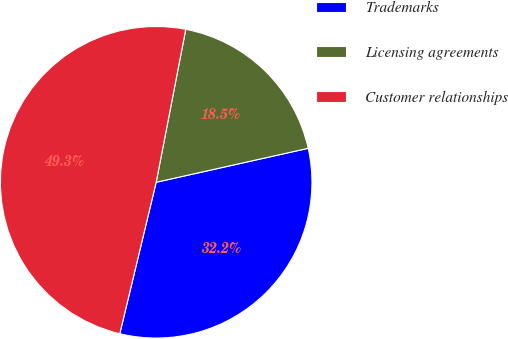Convert chart to OTSL. <chart><loc_0><loc_0><loc_500><loc_500><pie_chart><fcel>Trademarks<fcel>Licensing agreements<fcel>Customer relationships<nl><fcel>32.25%<fcel>18.46%<fcel>49.29%<nl></chart> 